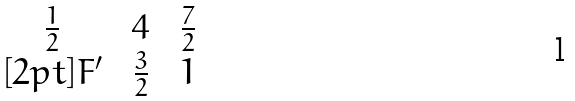<formula> <loc_0><loc_0><loc_500><loc_500>\begin{matrix} \frac { 1 } { 2 } \, & \, 4 \, & \, \frac { 7 } { 2 } \\ [ 2 p t ] F ^ { \prime } \, & \, \frac { 3 } { 2 } \, & \, 1 \end{matrix}</formula> 